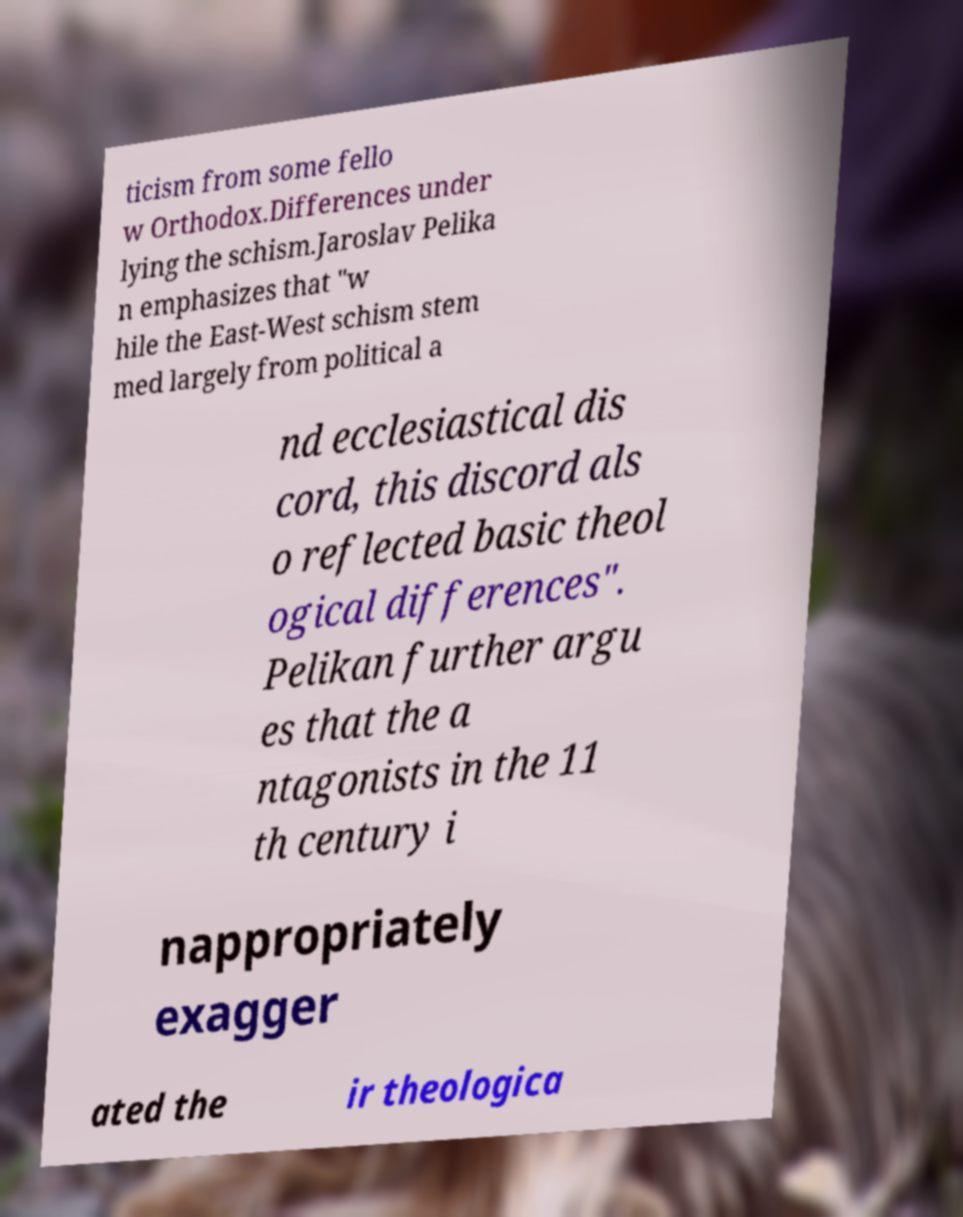What messages or text are displayed in this image? I need them in a readable, typed format. ticism from some fello w Orthodox.Differences under lying the schism.Jaroslav Pelika n emphasizes that "w hile the East-West schism stem med largely from political a nd ecclesiastical dis cord, this discord als o reflected basic theol ogical differences". Pelikan further argu es that the a ntagonists in the 11 th century i nappropriately exagger ated the ir theologica 